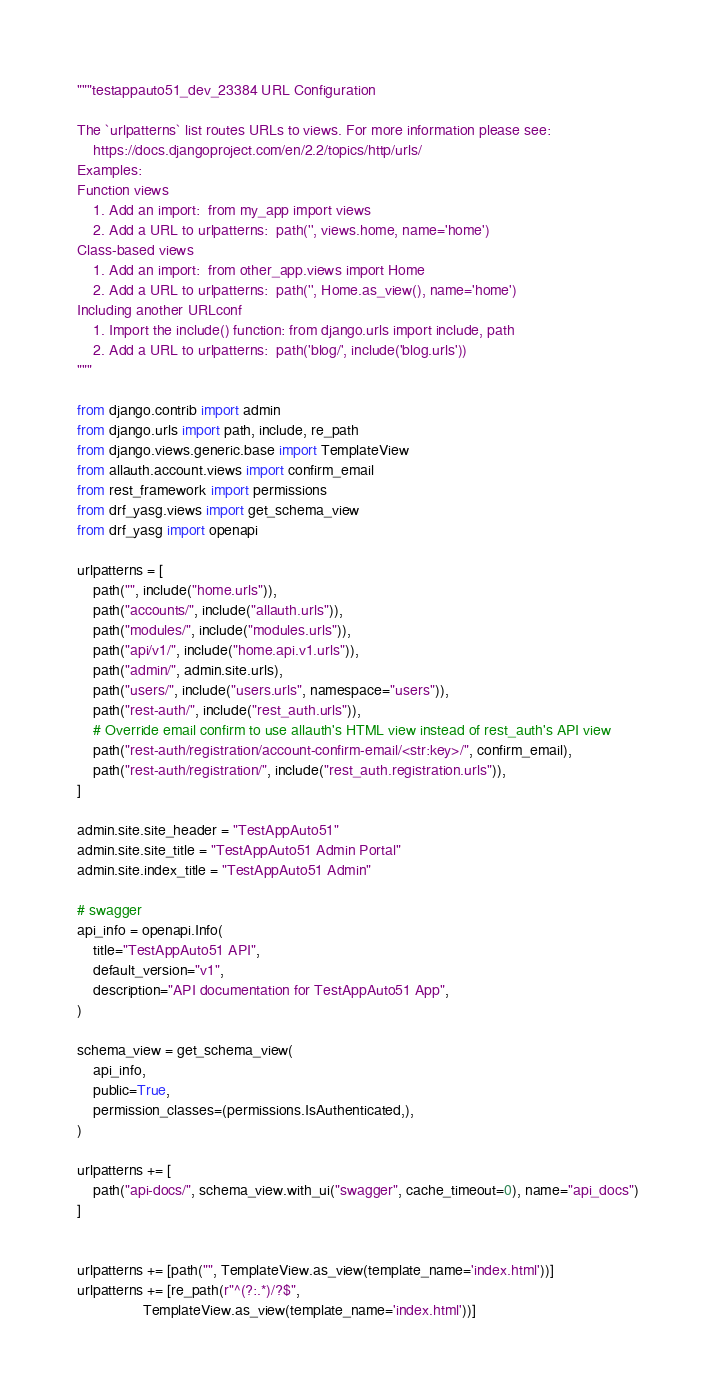<code> <loc_0><loc_0><loc_500><loc_500><_Python_>"""testappauto51_dev_23384 URL Configuration

The `urlpatterns` list routes URLs to views. For more information please see:
    https://docs.djangoproject.com/en/2.2/topics/http/urls/
Examples:
Function views
    1. Add an import:  from my_app import views
    2. Add a URL to urlpatterns:  path('', views.home, name='home')
Class-based views
    1. Add an import:  from other_app.views import Home
    2. Add a URL to urlpatterns:  path('', Home.as_view(), name='home')
Including another URLconf
    1. Import the include() function: from django.urls import include, path
    2. Add a URL to urlpatterns:  path('blog/', include('blog.urls'))
"""

from django.contrib import admin
from django.urls import path, include, re_path
from django.views.generic.base import TemplateView
from allauth.account.views import confirm_email
from rest_framework import permissions
from drf_yasg.views import get_schema_view
from drf_yasg import openapi

urlpatterns = [
    path("", include("home.urls")),
    path("accounts/", include("allauth.urls")),
    path("modules/", include("modules.urls")),
    path("api/v1/", include("home.api.v1.urls")),
    path("admin/", admin.site.urls),
    path("users/", include("users.urls", namespace="users")),
    path("rest-auth/", include("rest_auth.urls")),
    # Override email confirm to use allauth's HTML view instead of rest_auth's API view
    path("rest-auth/registration/account-confirm-email/<str:key>/", confirm_email),
    path("rest-auth/registration/", include("rest_auth.registration.urls")),
]

admin.site.site_header = "TestAppAuto51"
admin.site.site_title = "TestAppAuto51 Admin Portal"
admin.site.index_title = "TestAppAuto51 Admin"

# swagger
api_info = openapi.Info(
    title="TestAppAuto51 API",
    default_version="v1",
    description="API documentation for TestAppAuto51 App",
)

schema_view = get_schema_view(
    api_info,
    public=True,
    permission_classes=(permissions.IsAuthenticated,),
)

urlpatterns += [
    path("api-docs/", schema_view.with_ui("swagger", cache_timeout=0), name="api_docs")
]


urlpatterns += [path("", TemplateView.as_view(template_name='index.html'))]
urlpatterns += [re_path(r"^(?:.*)/?$",
                TemplateView.as_view(template_name='index.html'))]
</code> 